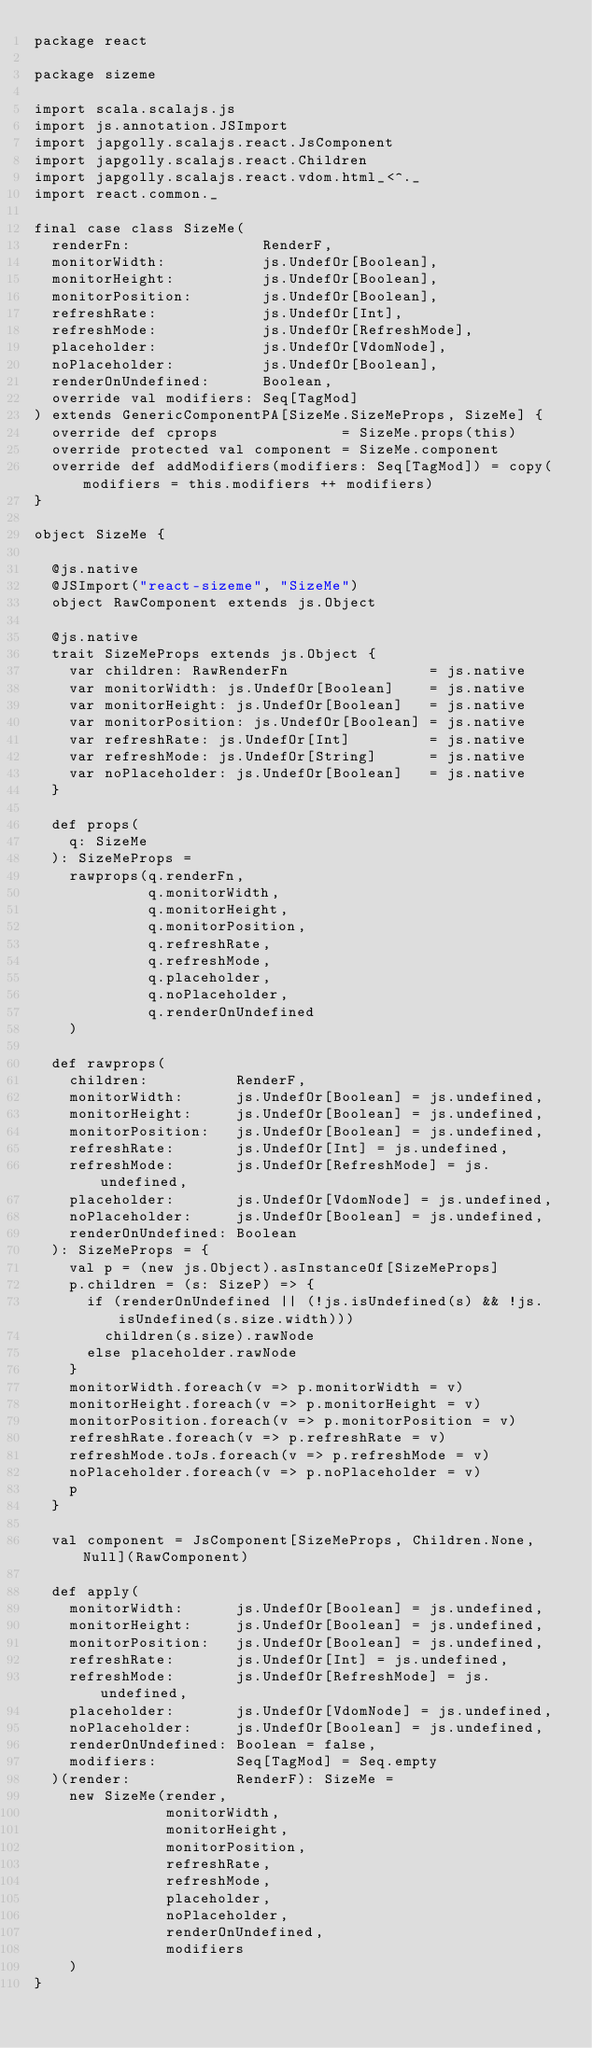<code> <loc_0><loc_0><loc_500><loc_500><_Scala_>package react

package sizeme

import scala.scalajs.js
import js.annotation.JSImport
import japgolly.scalajs.react.JsComponent
import japgolly.scalajs.react.Children
import japgolly.scalajs.react.vdom.html_<^._
import react.common._

final case class SizeMe(
  renderFn:               RenderF,
  monitorWidth:           js.UndefOr[Boolean],
  monitorHeight:          js.UndefOr[Boolean],
  monitorPosition:        js.UndefOr[Boolean],
  refreshRate:            js.UndefOr[Int],
  refreshMode:            js.UndefOr[RefreshMode],
  placeholder:            js.UndefOr[VdomNode],
  noPlaceholder:          js.UndefOr[Boolean],
  renderOnUndefined:      Boolean,
  override val modifiers: Seq[TagMod]
) extends GenericComponentPA[SizeMe.SizeMeProps, SizeMe] {
  override def cprops              = SizeMe.props(this)
  override protected val component = SizeMe.component
  override def addModifiers(modifiers: Seq[TagMod]) = copy(modifiers = this.modifiers ++ modifiers)
}

object SizeMe {

  @js.native
  @JSImport("react-sizeme", "SizeMe")
  object RawComponent extends js.Object

  @js.native
  trait SizeMeProps extends js.Object {
    var children: RawRenderFn                = js.native
    var monitorWidth: js.UndefOr[Boolean]    = js.native
    var monitorHeight: js.UndefOr[Boolean]   = js.native
    var monitorPosition: js.UndefOr[Boolean] = js.native
    var refreshRate: js.UndefOr[Int]         = js.native
    var refreshMode: js.UndefOr[String]      = js.native
    var noPlaceholder: js.UndefOr[Boolean]   = js.native
  }

  def props(
    q: SizeMe
  ): SizeMeProps =
    rawprops(q.renderFn,
             q.monitorWidth,
             q.monitorHeight,
             q.monitorPosition,
             q.refreshRate,
             q.refreshMode,
             q.placeholder,
             q.noPlaceholder,
             q.renderOnUndefined
    )

  def rawprops(
    children:          RenderF,
    monitorWidth:      js.UndefOr[Boolean] = js.undefined,
    monitorHeight:     js.UndefOr[Boolean] = js.undefined,
    monitorPosition:   js.UndefOr[Boolean] = js.undefined,
    refreshRate:       js.UndefOr[Int] = js.undefined,
    refreshMode:       js.UndefOr[RefreshMode] = js.undefined,
    placeholder:       js.UndefOr[VdomNode] = js.undefined,
    noPlaceholder:     js.UndefOr[Boolean] = js.undefined,
    renderOnUndefined: Boolean
  ): SizeMeProps = {
    val p = (new js.Object).asInstanceOf[SizeMeProps]
    p.children = (s: SizeP) => {
      if (renderOnUndefined || (!js.isUndefined(s) && !js.isUndefined(s.size.width)))
        children(s.size).rawNode
      else placeholder.rawNode
    }
    monitorWidth.foreach(v => p.monitorWidth = v)
    monitorHeight.foreach(v => p.monitorHeight = v)
    monitorPosition.foreach(v => p.monitorPosition = v)
    refreshRate.foreach(v => p.refreshRate = v)
    refreshMode.toJs.foreach(v => p.refreshMode = v)
    noPlaceholder.foreach(v => p.noPlaceholder = v)
    p
  }

  val component = JsComponent[SizeMeProps, Children.None, Null](RawComponent)

  def apply(
    monitorWidth:      js.UndefOr[Boolean] = js.undefined,
    monitorHeight:     js.UndefOr[Boolean] = js.undefined,
    monitorPosition:   js.UndefOr[Boolean] = js.undefined,
    refreshRate:       js.UndefOr[Int] = js.undefined,
    refreshMode:       js.UndefOr[RefreshMode] = js.undefined,
    placeholder:       js.UndefOr[VdomNode] = js.undefined,
    noPlaceholder:     js.UndefOr[Boolean] = js.undefined,
    renderOnUndefined: Boolean = false,
    modifiers:         Seq[TagMod] = Seq.empty
  )(render:            RenderF): SizeMe =
    new SizeMe(render,
               monitorWidth,
               monitorHeight,
               monitorPosition,
               refreshRate,
               refreshMode,
               placeholder,
               noPlaceholder,
               renderOnUndefined,
               modifiers
    )
}
</code> 